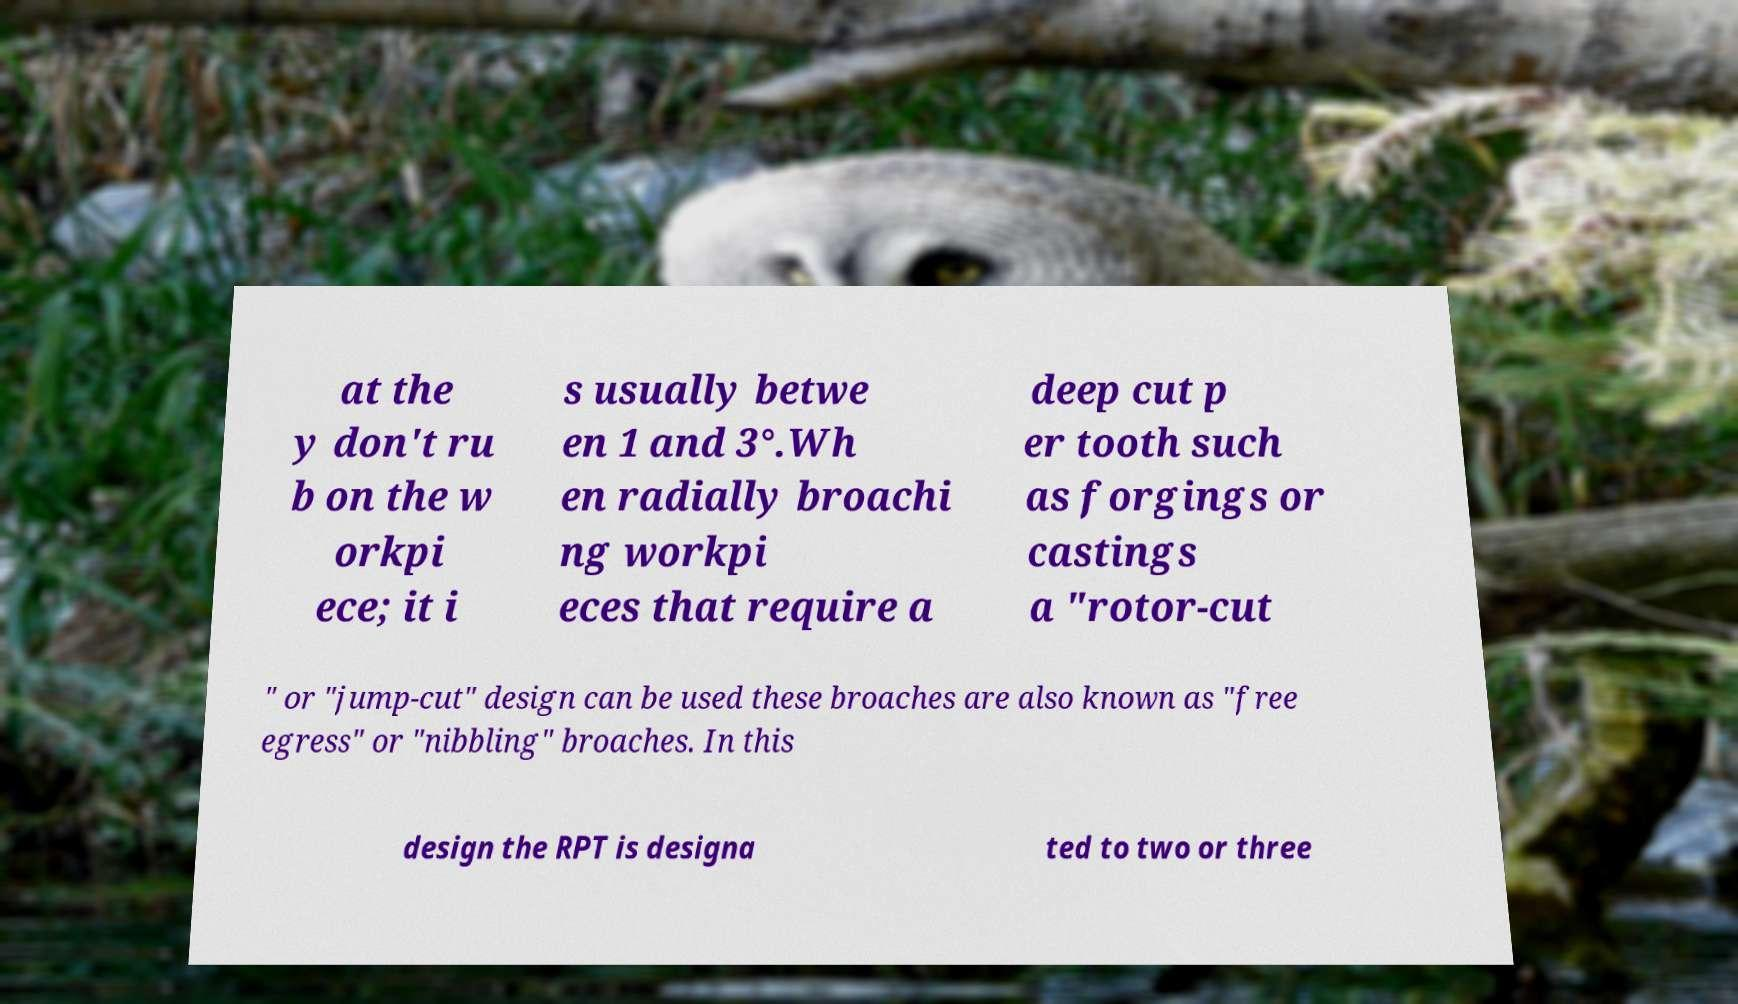Can you accurately transcribe the text from the provided image for me? at the y don't ru b on the w orkpi ece; it i s usually betwe en 1 and 3°.Wh en radially broachi ng workpi eces that require a deep cut p er tooth such as forgings or castings a "rotor-cut " or "jump-cut" design can be used these broaches are also known as "free egress" or "nibbling" broaches. In this design the RPT is designa ted to two or three 